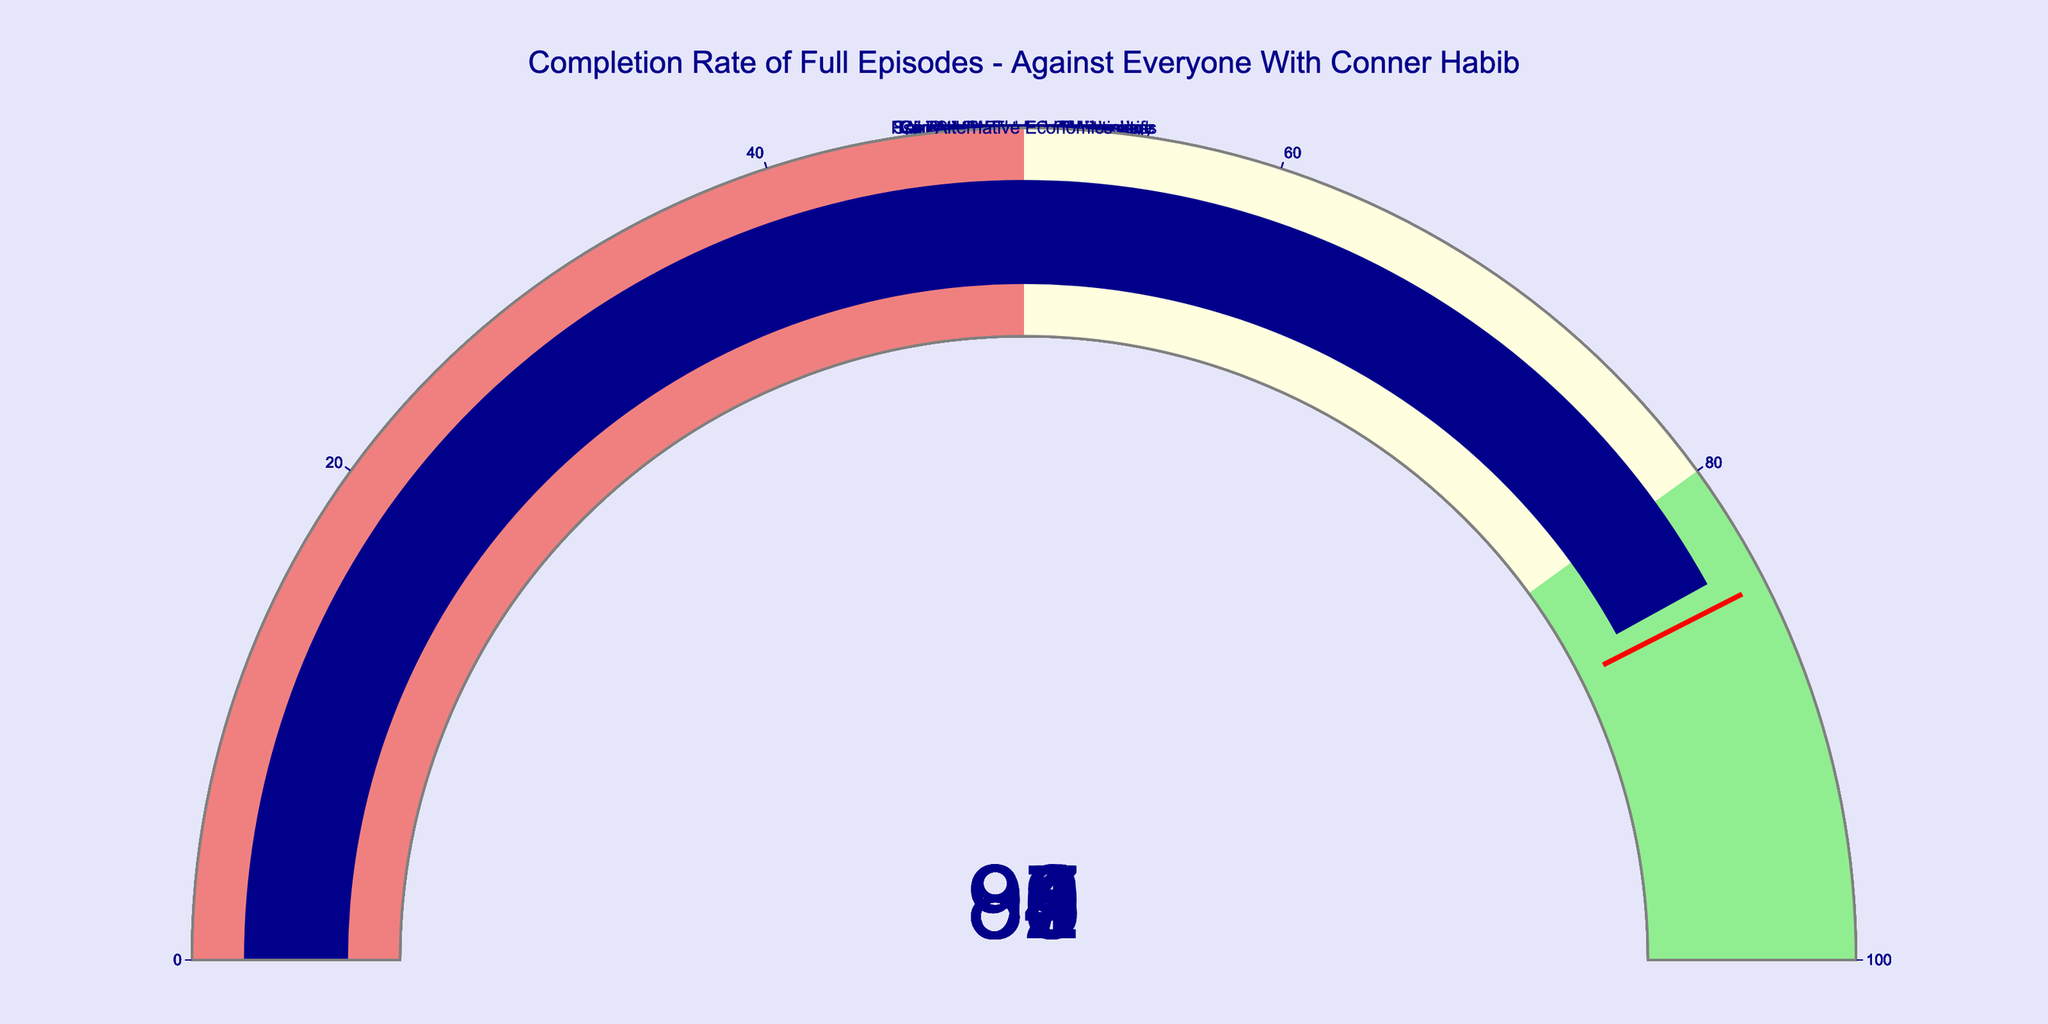What is the completion rate for the episode "Paranormal Experiences"? The gauge for "Paranormal Experiences" shows a value of 93.
Answer: 93 How many episodes have a completion rate above 90? The episodes with completion rates above 90 are "Psychedelics and Consciousness" (92), "Paranormal Experiences" (93), "Conspiracy Theories Unpacked" (91), and "Transhumanism and Technology" (90). That makes a total of 4 episodes.
Answer: 4 Which episode has the lowest completion rate? By looking at all the gauges, the episode "Alternative Economics" has the lowest completion rate with a value of 84.
Answer: Alternative Economics What is the average completion rate of all episodes? Add up the completion rates: 87 + 92 + 85 + 89 + 91 + 88 + 86 + 90 + 93 + 84 = 885. Then divide by the number of episodes, which is 10: 885 / 10 = 88.5.
Answer: 88.5 How does the completion rate of "Psychedelics and Consciousness" compare to "Occult Forces in Politics"? The completion rate of "Psychedelics and Consciousness" (92) is higher than "Occult Forces in Politics" (87).
Answer: "Psychedelics and Consciousness" is higher What is the median completion rate of the episodes? Arrange the completion rates in ascending order: 84, 85, 86, 87, 88, 89, 90, 91, 92, 93. The median is the average of the 5th and 6th values in this ordered list, so (88 + 89) / 2 = 88.5.
Answer: 88.5 Is there a majority of episodes with a completion rate in the "lightgreen" range (80-100)? Count the number of episodes in the "lightgreen" range (80-100): 87, 92, 85, 89, 91, 88, 86, 90, 93, 84. There are 9 episodes in this range. With 10 episodes in total, the majority is more than half, which would be more than 5.
Answer: Yes What are the episodes with completion rates between 85 and 90? The episodes within this range are "Occult Forces in Politics" (87), "Sex Work and Society" (85), "AI and the Future of Humanity" (89), "Spiritual Practices in Modern Life" (88), and "Climate Change and Mysticism" (86).
Answer: Occult Forces in Politics, Sex Work and Society, AI and the Future of Humanity, Spiritual Practices in Modern Life, Climate Change and Mysticism How much higher is the completion rate of "Psychedelics and Consciousness" compared to "Alternative Economics"? Subtract the completion rate of "Alternative Economics" (84) from "Psychedelics and Consciousness" (92): 92 - 84 = 8.
Answer: 8 